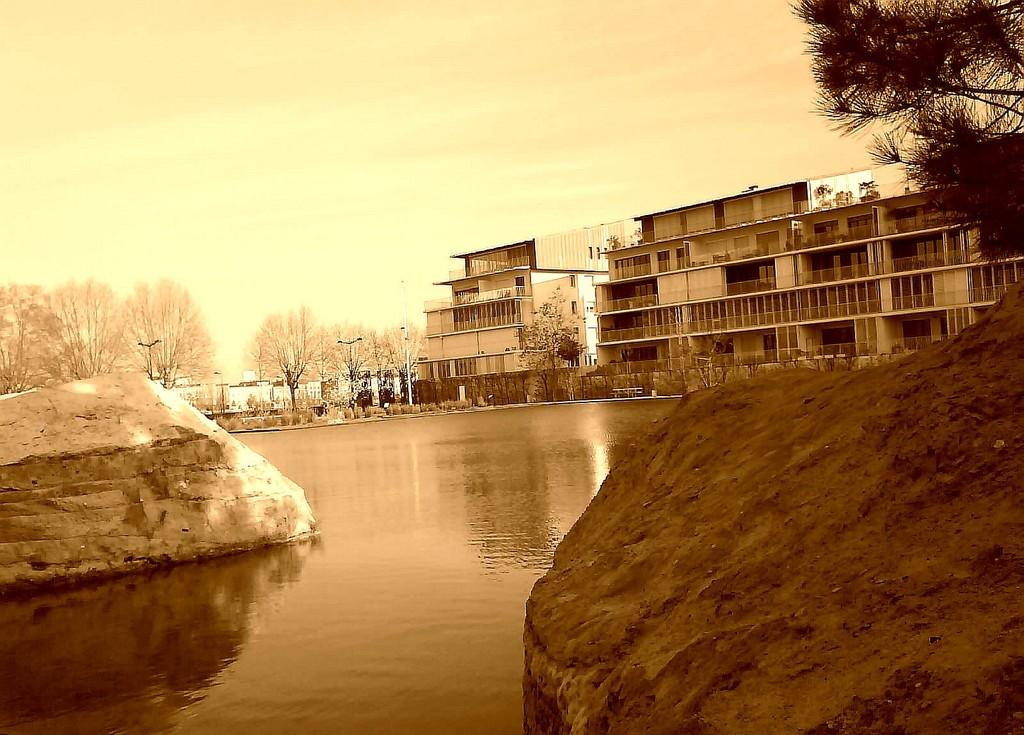What type of natural elements can be seen in the image? There are trees and plants in the image. What type of man-made structures are present in the image? There are buildings and fencing in the image. What type of lighting is present in the image? There are street lights in the image. What type of water body is visible in the image? There is a lake at the bottom of the image. What part of the natural environment is visible in the image? The sky is visible at the top of the image. Can you describe the worm crawling on the frame of the image? There is no worm present in the image, nor is there a frame around the image. 